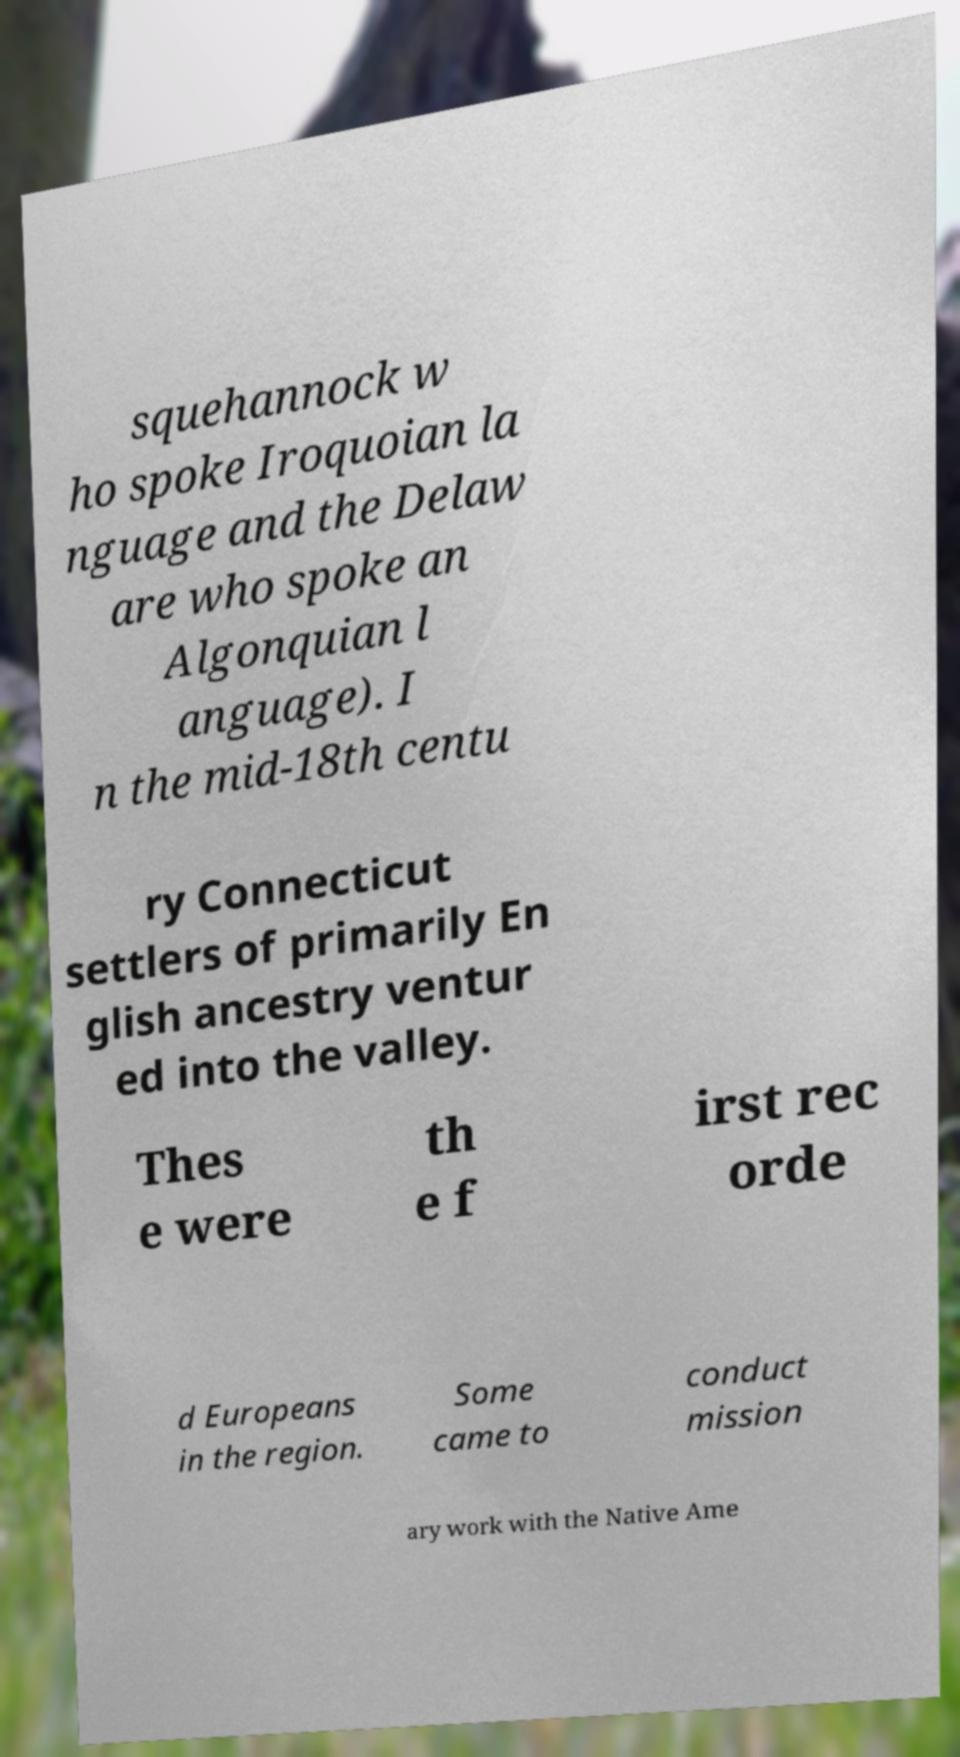Could you assist in decoding the text presented in this image and type it out clearly? squehannock w ho spoke Iroquoian la nguage and the Delaw are who spoke an Algonquian l anguage). I n the mid-18th centu ry Connecticut settlers of primarily En glish ancestry ventur ed into the valley. Thes e were th e f irst rec orde d Europeans in the region. Some came to conduct mission ary work with the Native Ame 